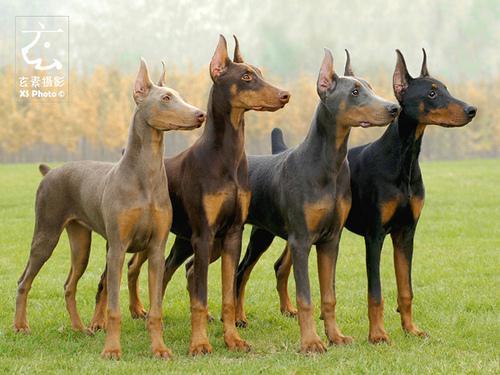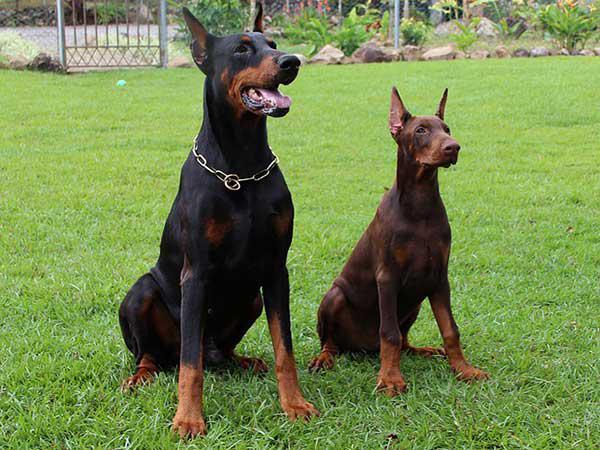The first image is the image on the left, the second image is the image on the right. Examine the images to the left and right. Is the description "One image includes a non-standing doberman wearing a chain collar, and the other image shows at least two dogs standing side-by-side on the grass." accurate? Answer yes or no. Yes. The first image is the image on the left, the second image is the image on the right. For the images shown, is this caption "The right image contains exactly two dogs." true? Answer yes or no. Yes. 